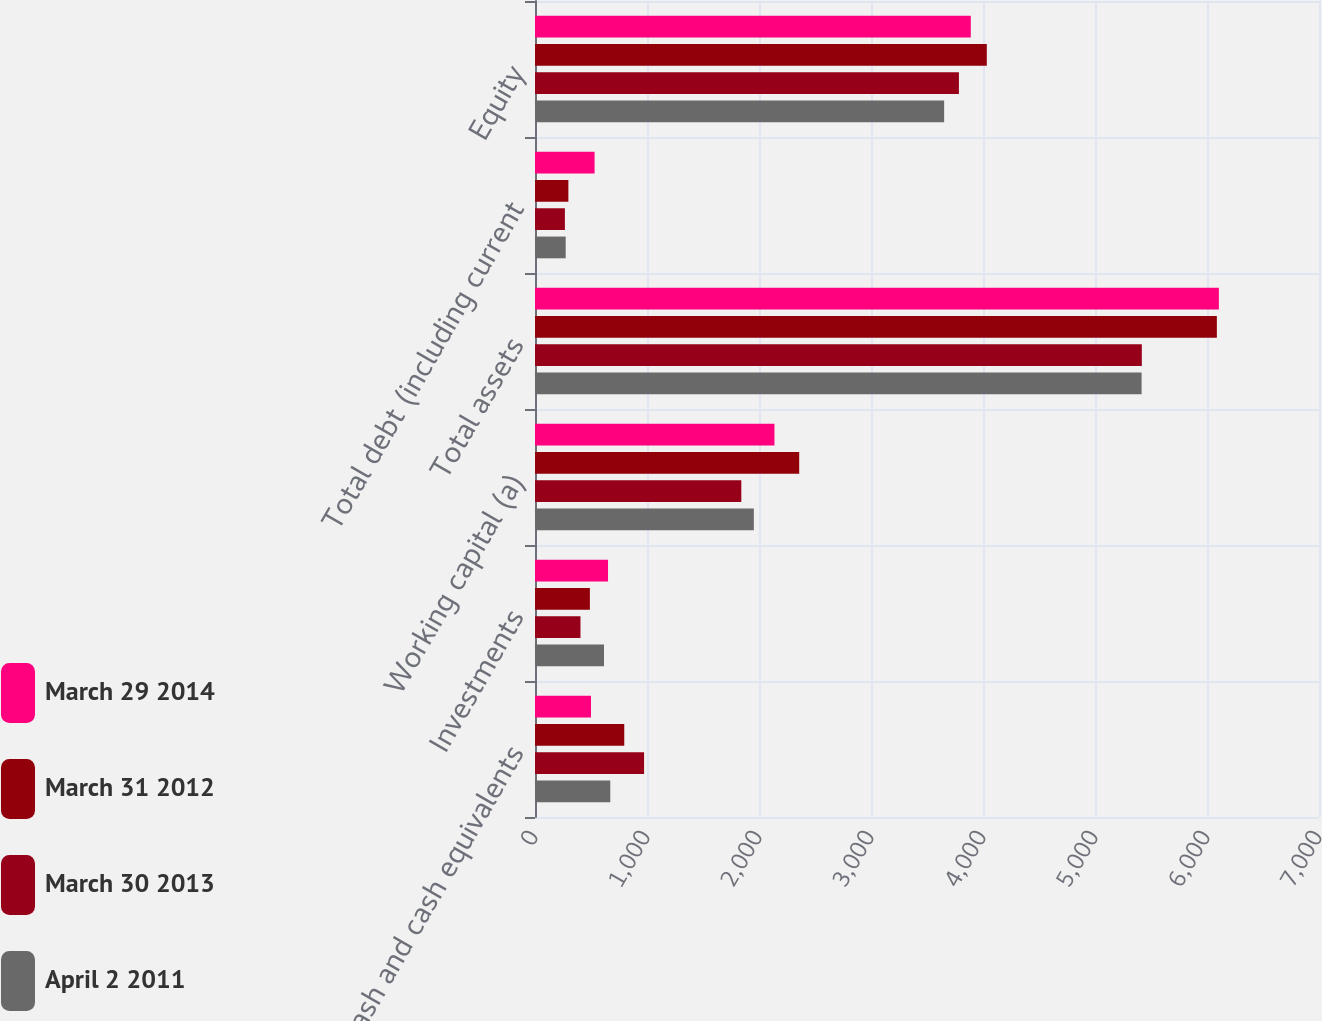Convert chart. <chart><loc_0><loc_0><loc_500><loc_500><stacked_bar_chart><ecel><fcel>Cash and cash equivalents<fcel>Investments<fcel>Working capital (a)<fcel>Total assets<fcel>Total debt (including current<fcel>Equity<nl><fcel>March 29 2014<fcel>500<fcel>652<fcel>2138<fcel>6106<fcel>532<fcel>3891<nl><fcel>March 31 2012<fcel>797<fcel>490<fcel>2359<fcel>6088<fcel>298<fcel>4034<nl><fcel>March 30 2013<fcel>974<fcel>406<fcel>1842<fcel>5418<fcel>267<fcel>3785<nl><fcel>April 2 2011<fcel>672<fcel>616<fcel>1954<fcel>5416<fcel>274<fcel>3653<nl></chart> 